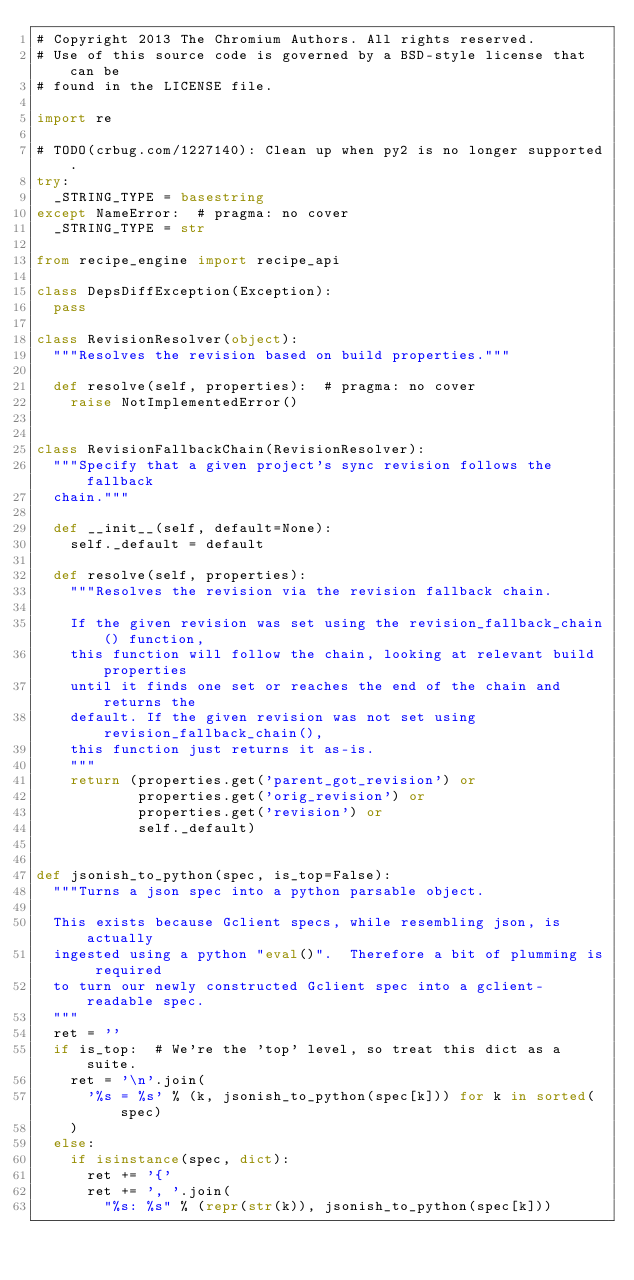<code> <loc_0><loc_0><loc_500><loc_500><_Python_># Copyright 2013 The Chromium Authors. All rights reserved.
# Use of this source code is governed by a BSD-style license that can be
# found in the LICENSE file.

import re

# TODO(crbug.com/1227140): Clean up when py2 is no longer supported.
try:
  _STRING_TYPE = basestring
except NameError:  # pragma: no cover
  _STRING_TYPE = str

from recipe_engine import recipe_api

class DepsDiffException(Exception):
  pass

class RevisionResolver(object):
  """Resolves the revision based on build properties."""

  def resolve(self, properties):  # pragma: no cover
    raise NotImplementedError()


class RevisionFallbackChain(RevisionResolver):
  """Specify that a given project's sync revision follows the fallback
  chain."""

  def __init__(self, default=None):
    self._default = default

  def resolve(self, properties):
    """Resolves the revision via the revision fallback chain.

    If the given revision was set using the revision_fallback_chain() function,
    this function will follow the chain, looking at relevant build properties
    until it finds one set or reaches the end of the chain and returns the
    default. If the given revision was not set using revision_fallback_chain(),
    this function just returns it as-is.
    """
    return (properties.get('parent_got_revision') or
            properties.get('orig_revision') or
            properties.get('revision') or
            self._default)


def jsonish_to_python(spec, is_top=False):
  """Turns a json spec into a python parsable object.

  This exists because Gclient specs, while resembling json, is actually
  ingested using a python "eval()".  Therefore a bit of plumming is required
  to turn our newly constructed Gclient spec into a gclient-readable spec.
  """
  ret = ''
  if is_top:  # We're the 'top' level, so treat this dict as a suite.
    ret = '\n'.join(
      '%s = %s' % (k, jsonish_to_python(spec[k])) for k in sorted(spec)
    )
  else:
    if isinstance(spec, dict):
      ret += '{'
      ret += ', '.join(
        "%s: %s" % (repr(str(k)), jsonish_to_python(spec[k]))</code> 